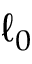<formula> <loc_0><loc_0><loc_500><loc_500>\ell _ { 0 }</formula> 